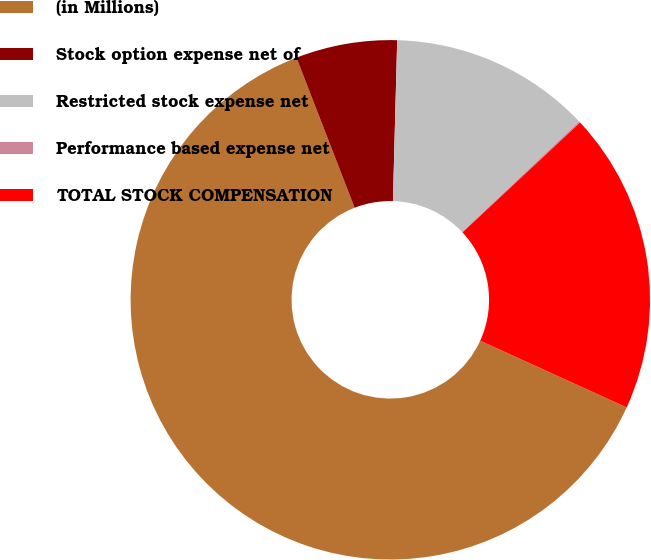Convert chart to OTSL. <chart><loc_0><loc_0><loc_500><loc_500><pie_chart><fcel>(in Millions)<fcel>Stock option expense net of<fcel>Restricted stock expense net<fcel>Performance based expense net<fcel>TOTAL STOCK COMPENSATION<nl><fcel>62.32%<fcel>6.31%<fcel>12.53%<fcel>0.09%<fcel>18.76%<nl></chart> 